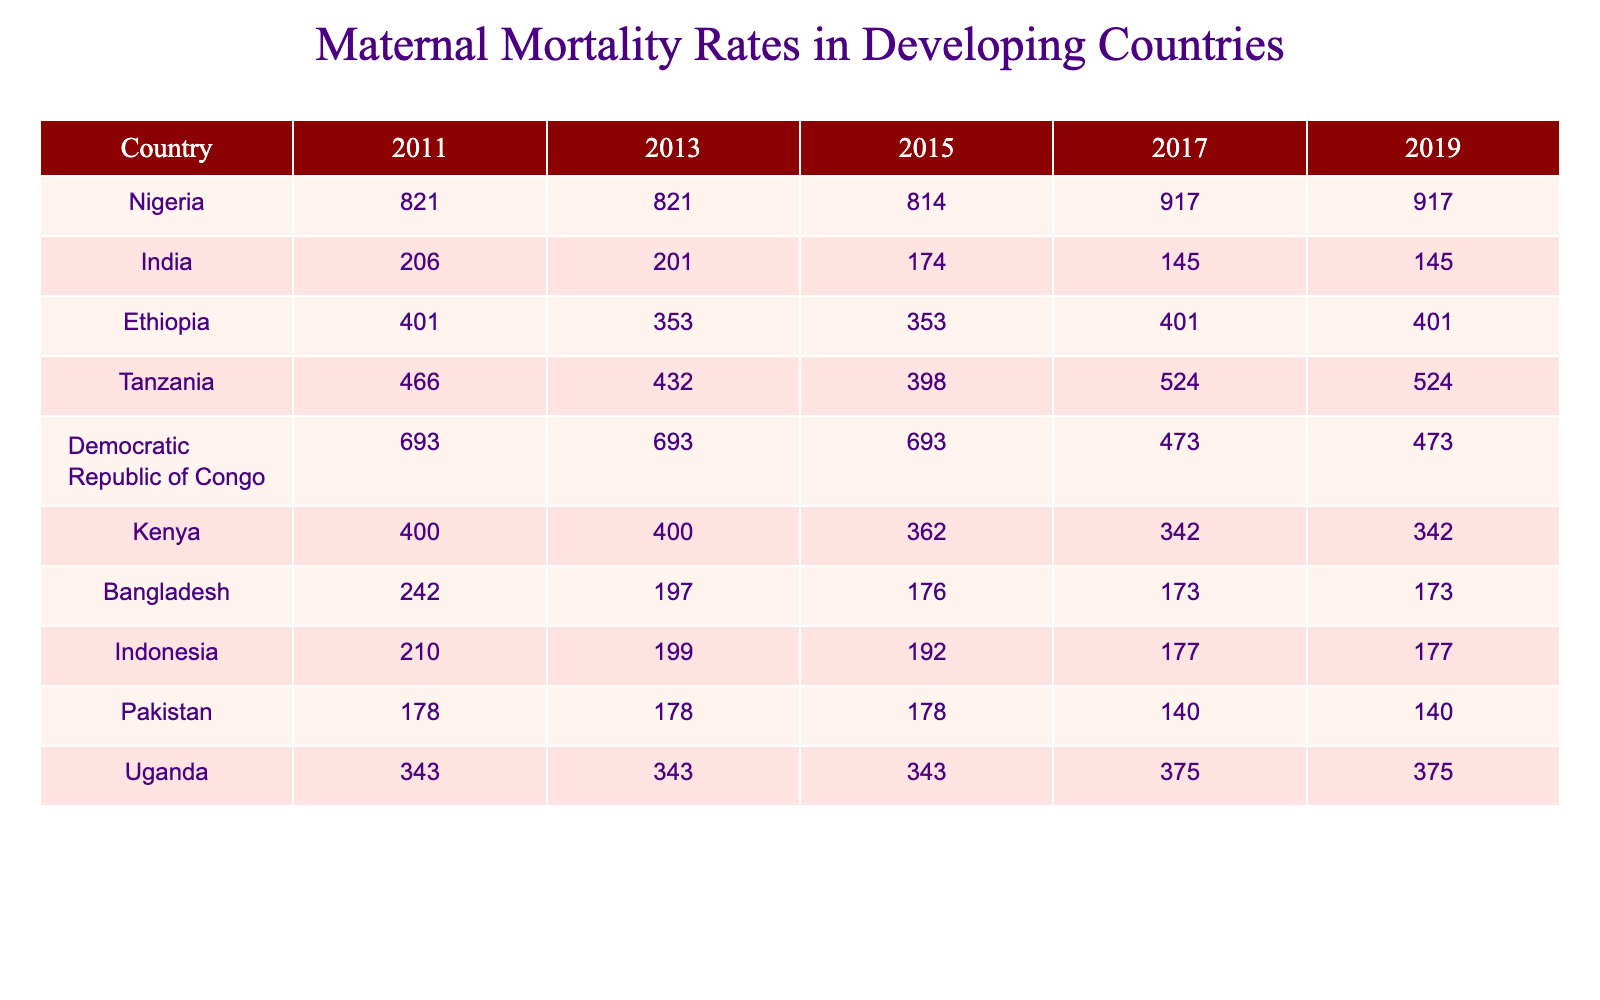What is the maternal mortality rate in Nigeria in 2019? From the table, the maternal mortality rate for Nigeria in 2019 is directly provided in the respective column, which is 917.
Answer: 917 Which country had the highest maternal mortality rate in 2015? Looking at the 2015 column of the table, Nigeria (814) has the highest rate compared to all other countries listed.
Answer: Nigeria What is the change in maternal mortality rate for India from 2011 to 2019? The rate in 2011 was 206 and in 2019 it is 145. The change is calculated as 206 - 145 = 61, indicating a decrease.
Answer: Decrease of 61 Which country shows the largest increase in maternal mortality rate from 2017 to 2019? Reviewing the 2017 and 2019 columns, Tanzania's rate increased from 524 to 524 (no change), while others decreased or remained the same. Therefore, no country showed an increase, and we look for those that did not decrease.
Answer: No increase What is the average maternal mortality rate for Ethiopia over the decade? The rates for Ethiopia are: 401, 353, 353, 401, 401. The sum is 401 + 353 + 353 + 401 + 401 = 1909, dividing by 5 gives an average of 1909 / 5 = 381.8.
Answer: 381.8 Did Kenya's maternal mortality rate improve from 2011 to 2017? The rates are 400 in 2011 and 342 in 2017. Since 342 is less than 400, this indicates an improvement in maternal mortality for Kenya.
Answer: Yes What is the median maternal mortality rate in 2013 among the countries listed? The rates in 2013 are: 821 (Nigeria), 201 (India), 353 (Ethiopia), 432 (Tanzania), 693 (DRC), 400 (Kenya), 197 (Bangladesh), 199 (Indonesia), 178 (Pakistan), 343 (Uganda). Ordering these gives: 178, 197, 201, 353, 400, 432, 693, 821. The median (the middle value) is 353, as there are 10 entries.
Answer: 353 Which country maintained the same maternal mortality rate across all years? Upon inspecting the data, Democratic Republic of Congo has consistently had a maternal mortality rate of 693 over the years examined, indicating no changes.
Answer: Democratic Republic of Congo What was the trend of maternal mortality rates in Bangladesh from 2011 to 2019? The values for Bangladesh are: 242 (2011), 197 (2013), 176 (2015), 173 (2017), and 173 (2019). The rates show a consistent decrease from 242 in 2011 to 173 in 2019.
Answer: Consistent decrease In 2015, which two countries had maternal mortality rates equal to or below 200? From the 2015 column, the countries with rates equal to or below 200 are India (174) and Bangladesh (176). Both of these are less than 200.
Answer: India and Bangladesh 